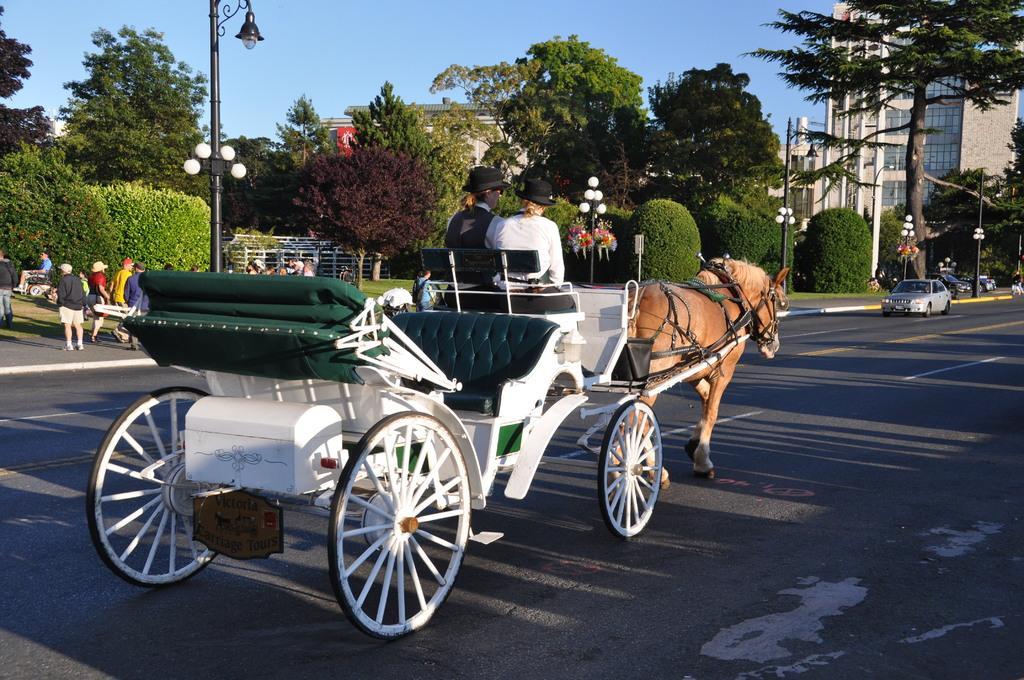Describe this image in one or two sentences. In this image we can see a horse cart on the road and persons sitting on it. In the background there are sky, buildings, trees, street poles, street lights, motor vehicles on the road, fence, bushes, persons sitting on the chairs and persons walking on the road. 